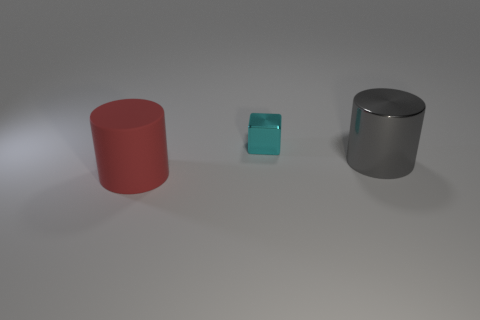Subtract all red cylinders. How many cylinders are left? 1 Subtract 1 blocks. How many blocks are left? 0 Add 3 big brown shiny things. How many objects exist? 6 Subtract all cylinders. How many objects are left? 1 Subtract 1 cyan cubes. How many objects are left? 2 Subtract all red cylinders. Subtract all brown cubes. How many cylinders are left? 1 Subtract all red cubes. How many red cylinders are left? 1 Subtract all metal cubes. Subtract all big red matte objects. How many objects are left? 1 Add 3 big metallic things. How many big metallic things are left? 4 Add 3 purple blocks. How many purple blocks exist? 3 